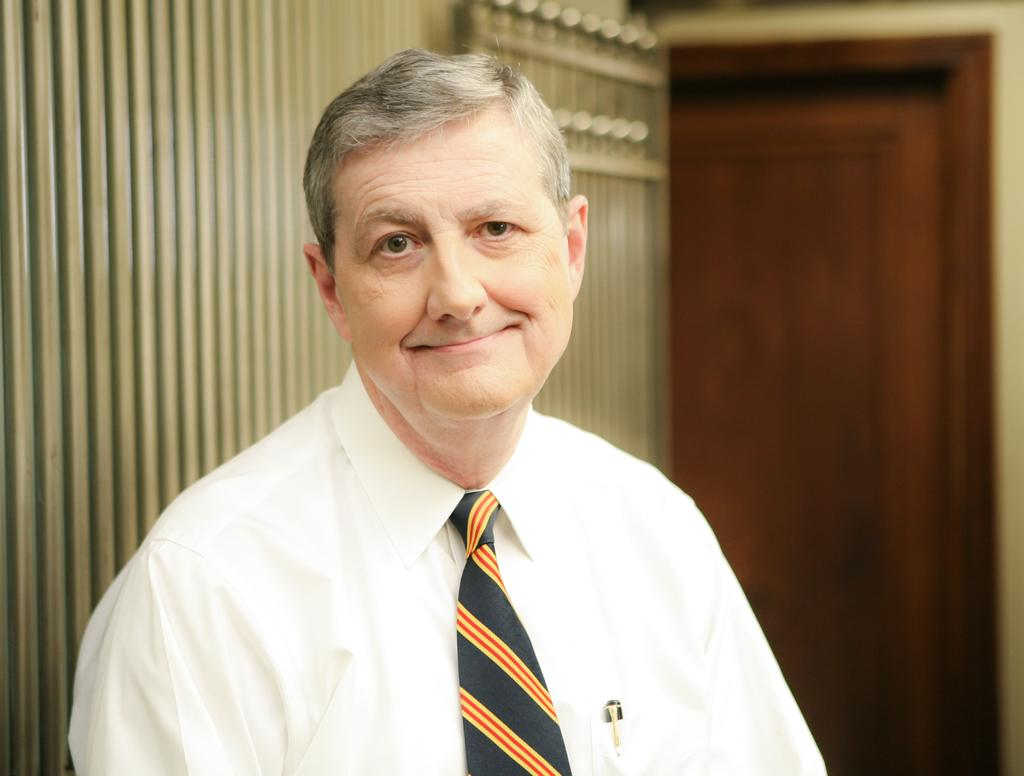Who is present in the image? There is a man in the image. What is the man doing in the image? The man is looking to his side. What type of clothing is the man wearing? The man is wearing a tie and a shirt. What can be seen on the right side of the image? There is a door on the right side of the image. What type of fowl can be seen crying in the image? There is no fowl present in the image, and no one is crying. 